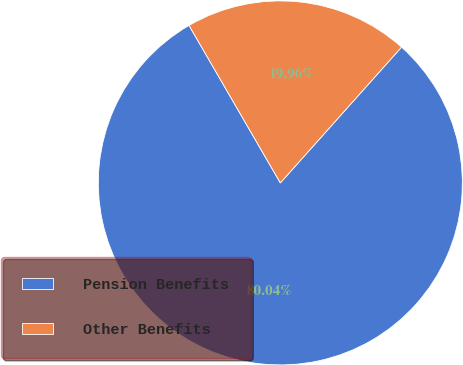Convert chart to OTSL. <chart><loc_0><loc_0><loc_500><loc_500><pie_chart><fcel>Pension Benefits<fcel>Other Benefits<nl><fcel>80.04%<fcel>19.96%<nl></chart> 